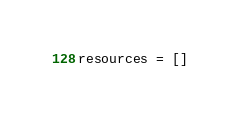<code> <loc_0><loc_0><loc_500><loc_500><_Python_>resources = []
</code> 